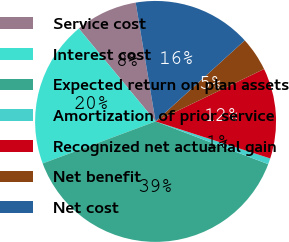Convert chart to OTSL. <chart><loc_0><loc_0><loc_500><loc_500><pie_chart><fcel>Service cost<fcel>Interest cost<fcel>Expected return on plan assets<fcel>Amortization of prior service<fcel>Recognized net actuarial gain<fcel>Net benefit<fcel>Net cost<nl><fcel>8.35%<fcel>19.68%<fcel>38.55%<fcel>0.8%<fcel>12.13%<fcel>4.58%<fcel>15.9%<nl></chart> 